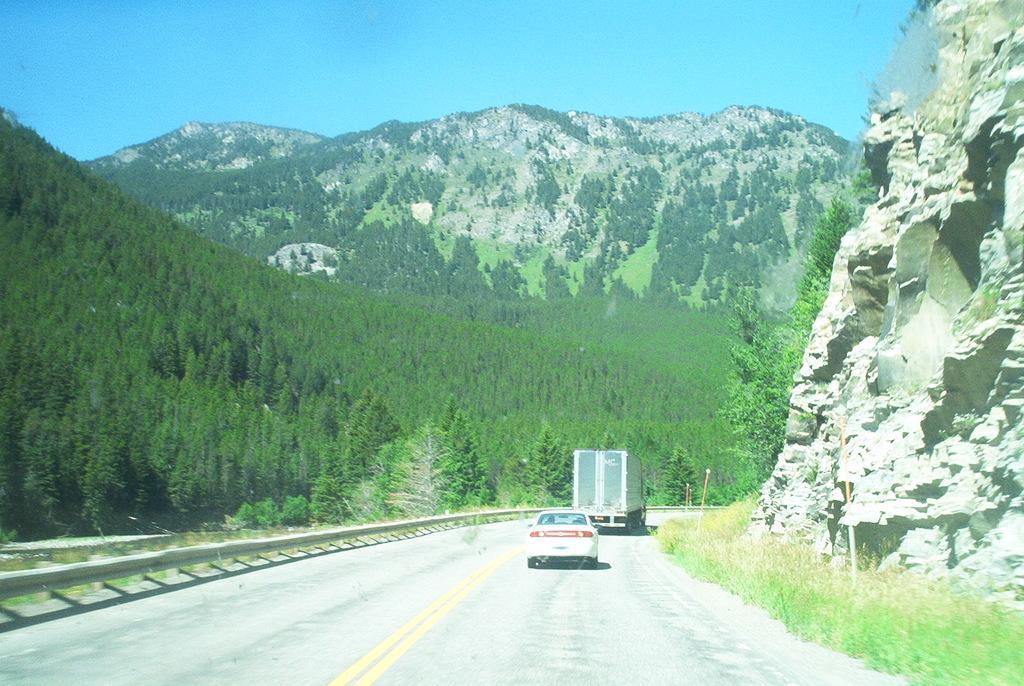How would you summarize this image in a sentence or two? In this image there are two vehicles passing on the motorway, on the either side of the road there are trees and mountains. 